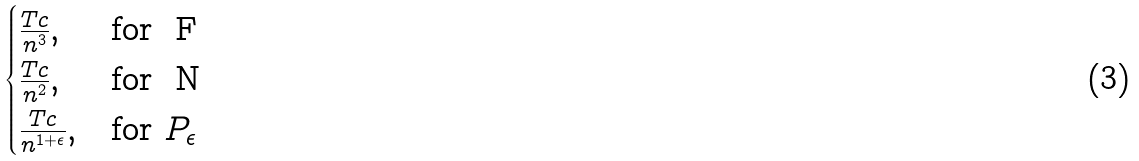Convert formula to latex. <formula><loc_0><loc_0><loc_500><loc_500>\begin{cases} \frac { T c } { n ^ { 3 } } , & \text {for } $ F $ \\ \frac { T c } { n ^ { 2 } } , & \text {for } $ N $ \\ \frac { T c } { n ^ { 1 + \epsilon } } , & \text {for } P _ { \epsilon } \end{cases}</formula> 